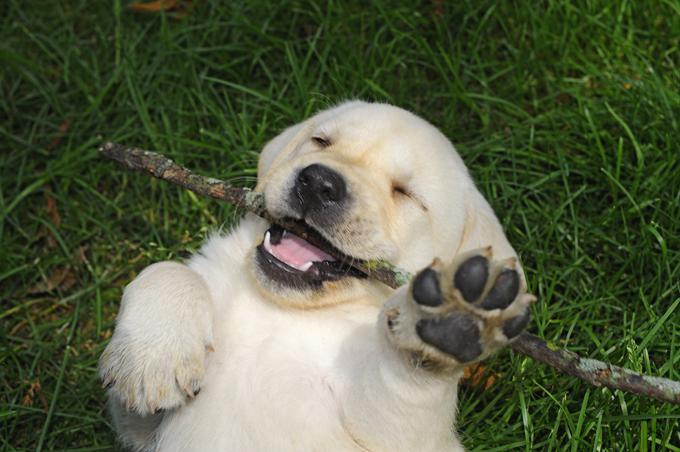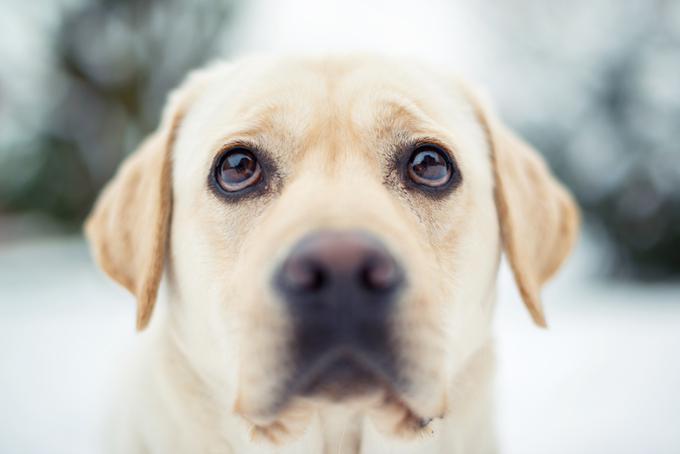The first image is the image on the left, the second image is the image on the right. Examine the images to the left and right. Is the description "An image shows a puppy with tongue showing and something in its mouth." accurate? Answer yes or no. Yes. The first image is the image on the left, the second image is the image on the right. Considering the images on both sides, is "The dog in the grass in the image on the left has something to play with." valid? Answer yes or no. Yes. 